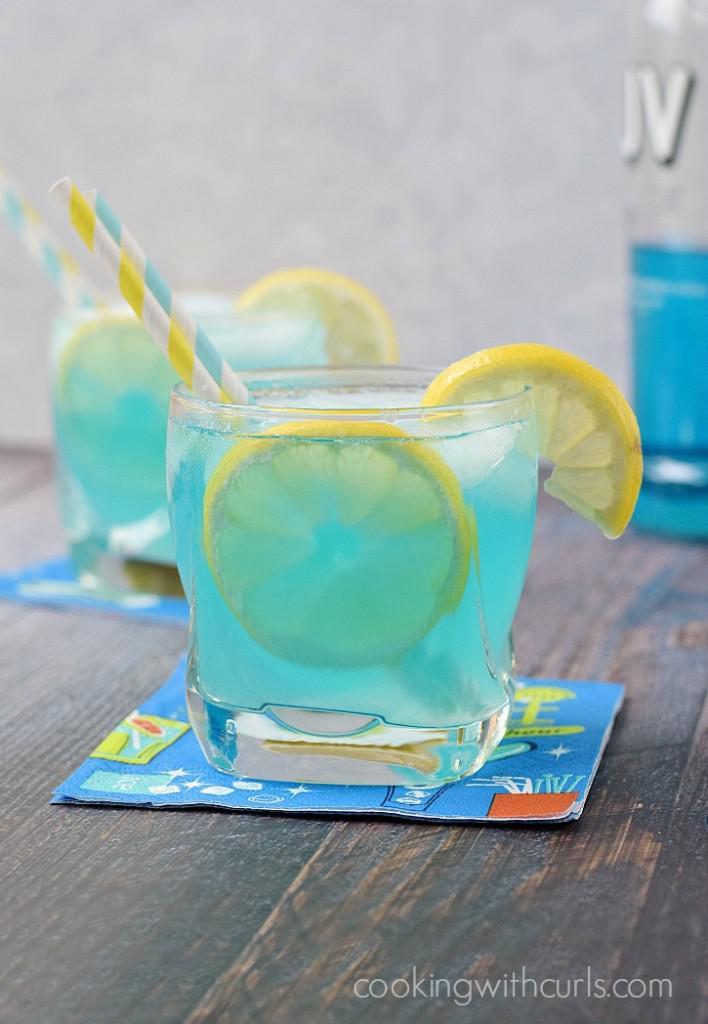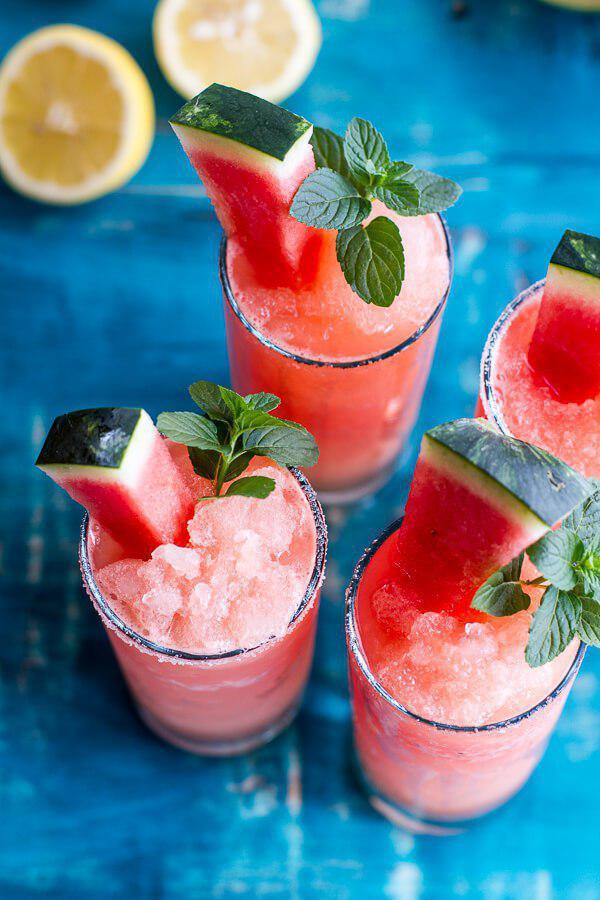The first image is the image on the left, the second image is the image on the right. For the images displayed, is the sentence "Dessert drinks in one image are pink in tall glasses, and in the other are pink in short glasses." factually correct? Answer yes or no. No. The first image is the image on the left, the second image is the image on the right. Given the left and right images, does the statement "There are no more than 5 full drink glasses." hold true? Answer yes or no. No. 